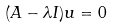<formula> <loc_0><loc_0><loc_500><loc_500>( A - \lambda I ) u = 0</formula> 